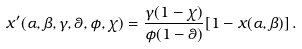<formula> <loc_0><loc_0><loc_500><loc_500>x ^ { \prime } ( \alpha , \beta , \gamma , \theta , \phi , \chi ) = \frac { \gamma ( 1 - \chi ) } { \phi ( 1 - \theta ) } [ 1 - x ( \alpha , \beta ) ] \, .</formula> 